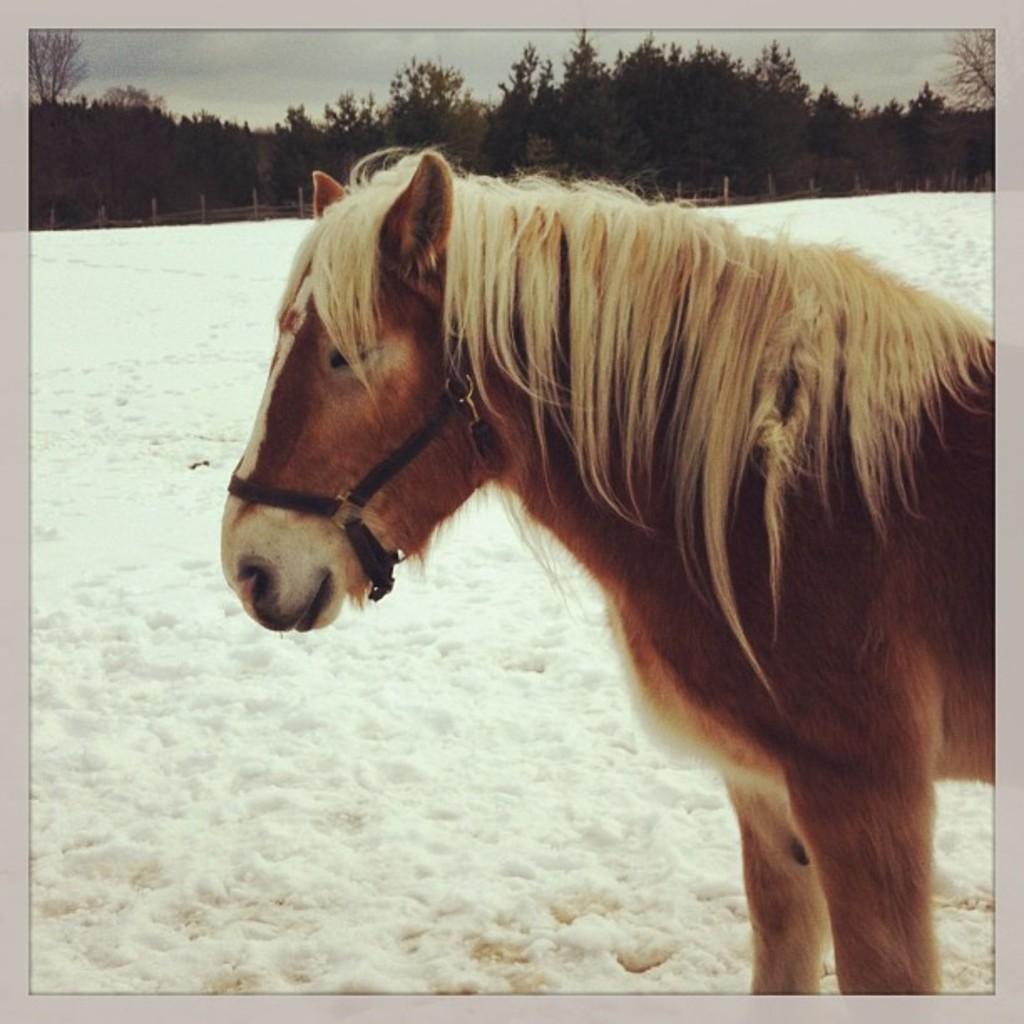In one or two sentences, can you explain what this image depicts? In this picture, we see a horse. At the bottom, we see the snow. In the background, we see the wooden fence and the trees. At the top, we see the sky. This picture might be a photo frame. 